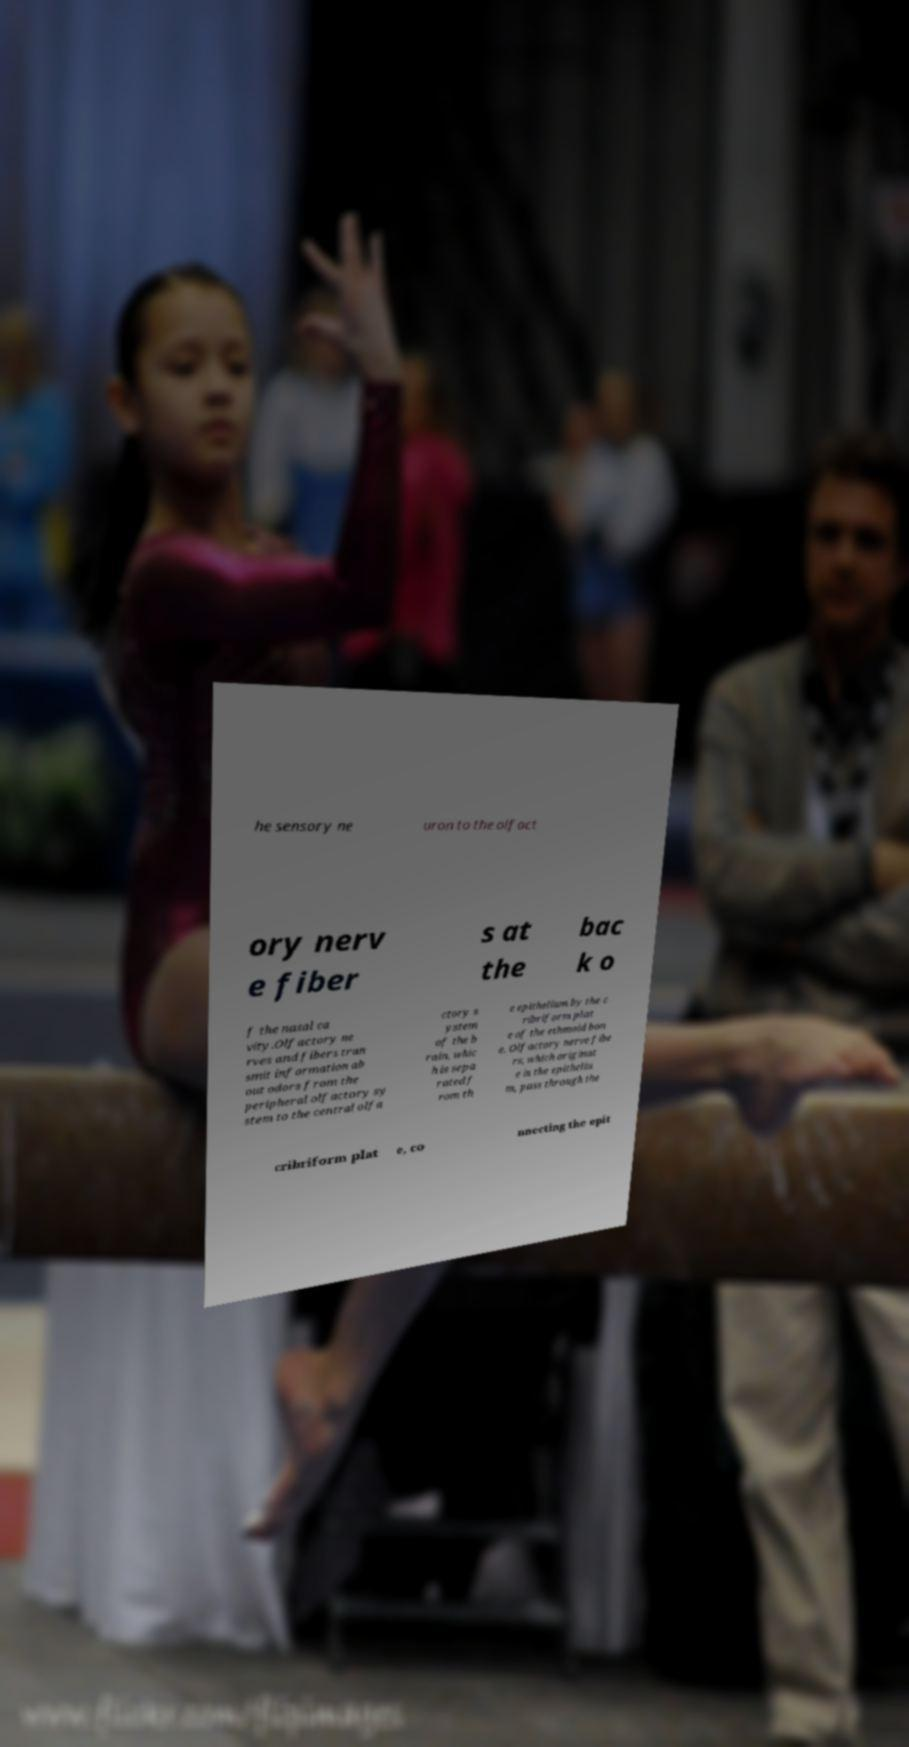For documentation purposes, I need the text within this image transcribed. Could you provide that? he sensory ne uron to the olfact ory nerv e fiber s at the bac k o f the nasal ca vity.Olfactory ne rves and fibers tran smit information ab out odors from the peripheral olfactory sy stem to the central olfa ctory s ystem of the b rain, whic h is sepa rated f rom th e epithelium by the c ribriform plat e of the ethmoid bon e. Olfactory nerve fibe rs, which originat e in the epitheliu m, pass through the cribriform plat e, co nnecting the epit 